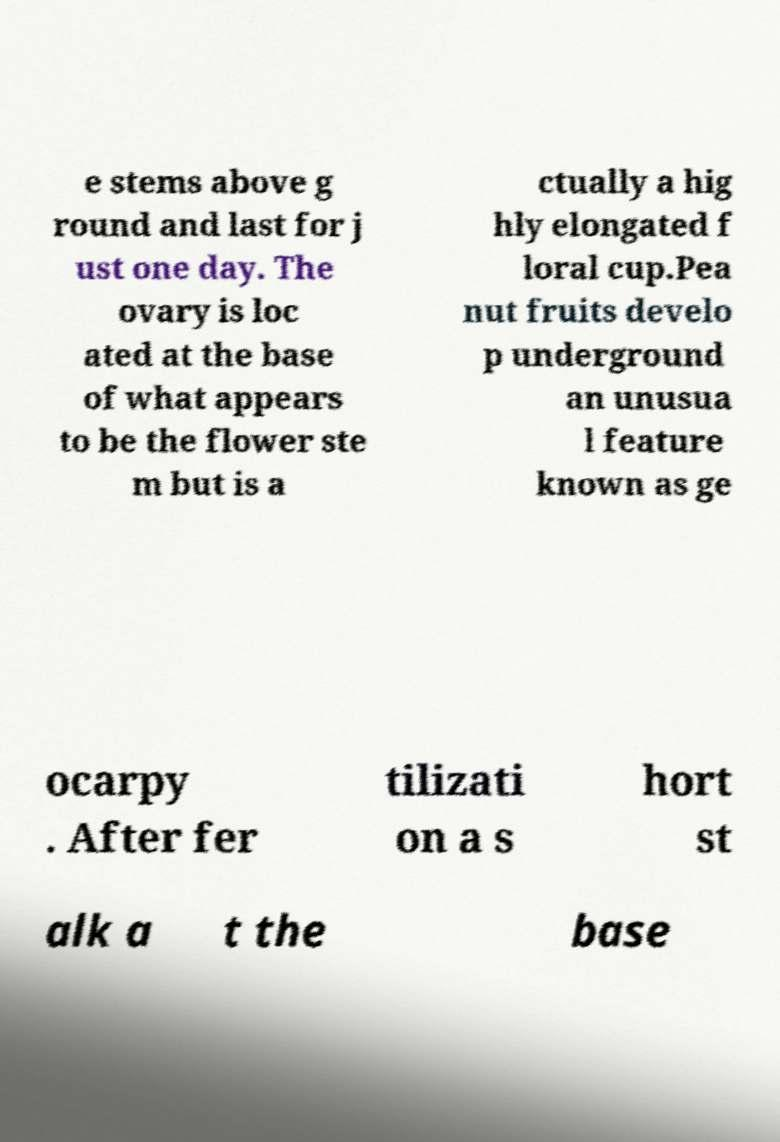Can you read and provide the text displayed in the image?This photo seems to have some interesting text. Can you extract and type it out for me? e stems above g round and last for j ust one day. The ovary is loc ated at the base of what appears to be the flower ste m but is a ctually a hig hly elongated f loral cup.Pea nut fruits develo p underground an unusua l feature known as ge ocarpy . After fer tilizati on a s hort st alk a t the base 